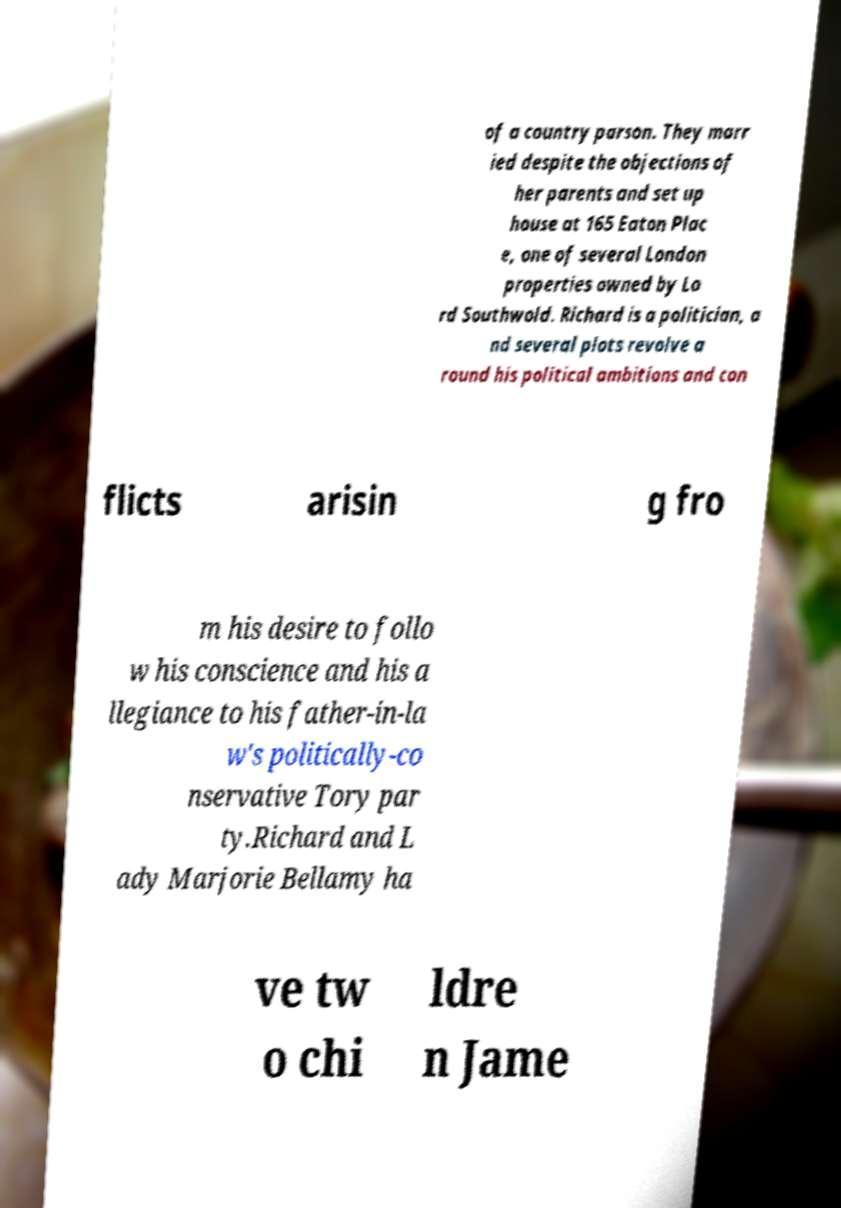What messages or text are displayed in this image? I need them in a readable, typed format. of a country parson. They marr ied despite the objections of her parents and set up house at 165 Eaton Plac e, one of several London properties owned by Lo rd Southwold. Richard is a politician, a nd several plots revolve a round his political ambitions and con flicts arisin g fro m his desire to follo w his conscience and his a llegiance to his father-in-la w's politically-co nservative Tory par ty.Richard and L ady Marjorie Bellamy ha ve tw o chi ldre n Jame 